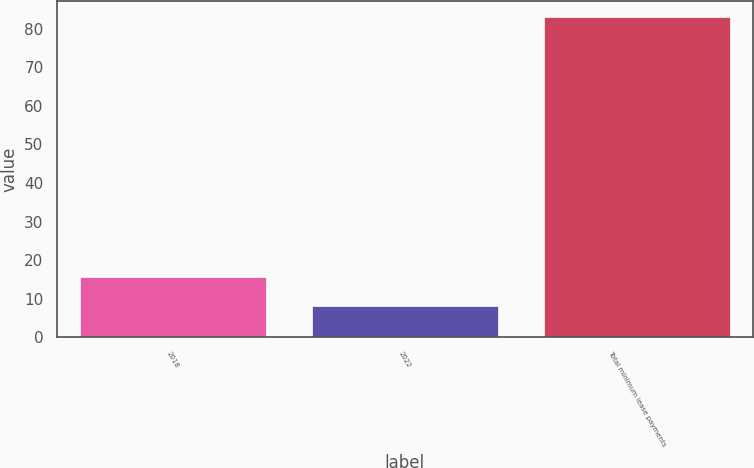Convert chart. <chart><loc_0><loc_0><loc_500><loc_500><bar_chart><fcel>2018<fcel>2022<fcel>Total minimum lease payments<nl><fcel>15.5<fcel>8<fcel>83<nl></chart> 